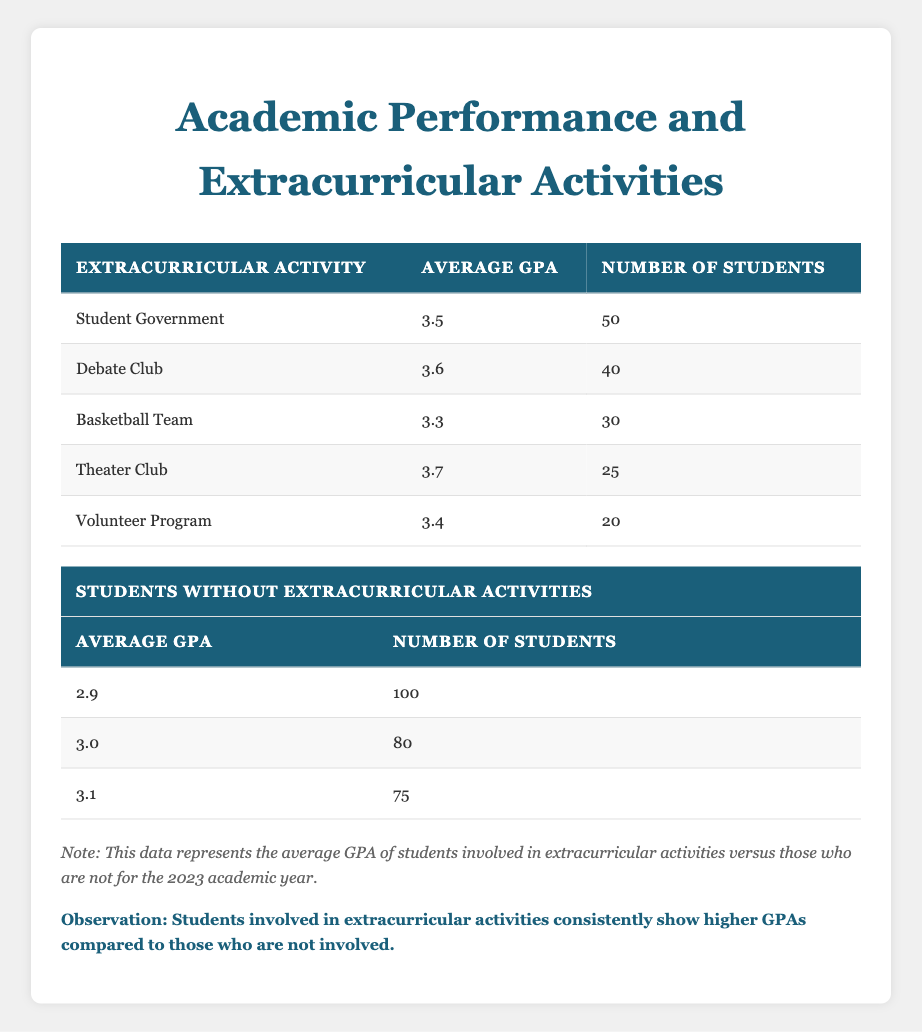What is the average GPA of students involved in the Theater Club? The table indicates that the average GPA of students in the Theater Club is listed as 3.7.
Answer: 3.7 How many students are involved in the Debate Club? The table shows that 40 students are involved in the Debate Club.
Answer: 40 What is the average GPA of students without extracurricular activities? The table provides three average GPAs for students without extracurricular activities: 2.9, 3.0, and 3.1. The question asks for an average, which can be found by calculating (2.9 + 3.0 + 3.1)/3 = 2.99.
Answer: 2.99 Is the average GPA of students in the Student Government greater than those in the Basketball Team? The average GPA for the Student Government is 3.5 and for the Basketball Team is 3.3. Since 3.5 is greater than 3.3, the statement is true.
Answer: Yes What is the total number of students involved in all extracurricular activities listed? To find the total, sum the number of students in each activity: 50 (Student Government) + 40 (Debate Club) + 30 (Basketball Team) + 25 (Theater Club) + 20 (Volunteer Program) = 165.
Answer: 165 How does the average GPA of students in the Volunteer Program compare to those not involved in extracurricular activities? The average GPA in the Volunteer Program is 3.4, while the highest average GPA for students without activities is 3.1. Since 3.4 is greater than 3.1, students in the Volunteer Program perform better.
Answer: 3.4 is greater than 3.1 What proportion of students not involved in extracurricular activities has a GPA higher than 3.0? Out of the three average GPAs for students without activities, only the one for 3.1 is higher than 3.0. So, one out of three GPAs is above 3.0, giving a proportion of 1/3 or approximately 33.33%.
Answer: 33.33% Which extracurricular activity has the highest average GPA? By examining the average GPAs in the table, the Theater Club has the highest at 3.7.
Answer: Theater Club What is the difference between the highest and lowest average GPA among students involved in extracurricular activities? The highest average GPA is 3.7 (Theater Club) and the lowest is 3.3 (Basketball Team). The difference is calculated as 3.7 - 3.3 = 0.4.
Answer: 0.4 